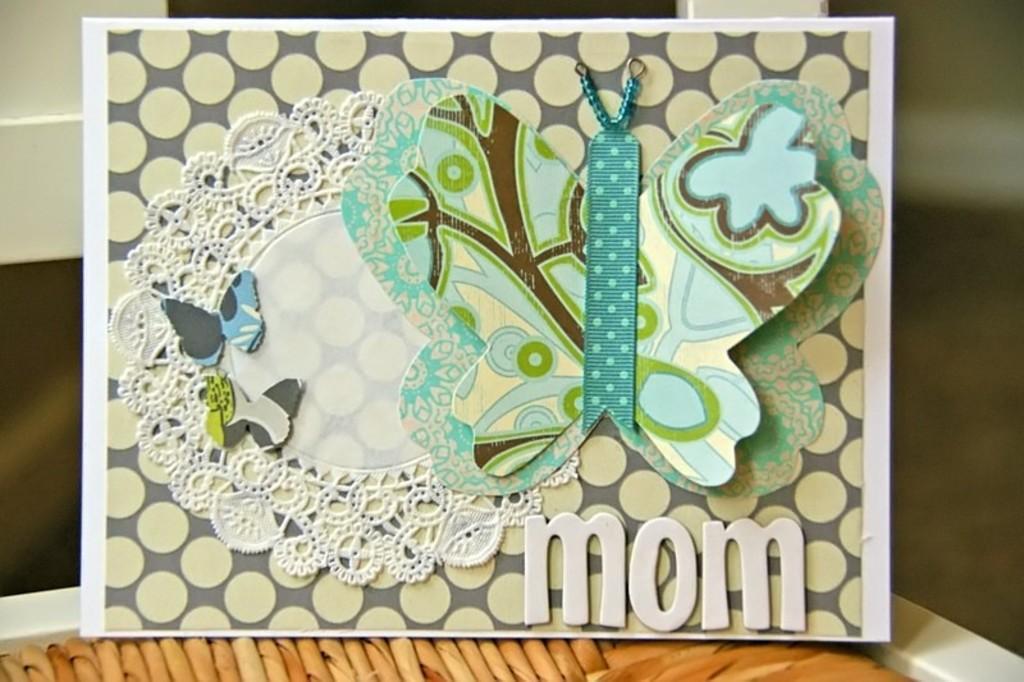Could you give a brief overview of what you see in this image? In this image I can see the board. On the board I can see few stickers of the butterflies and I can see the blurred background. 